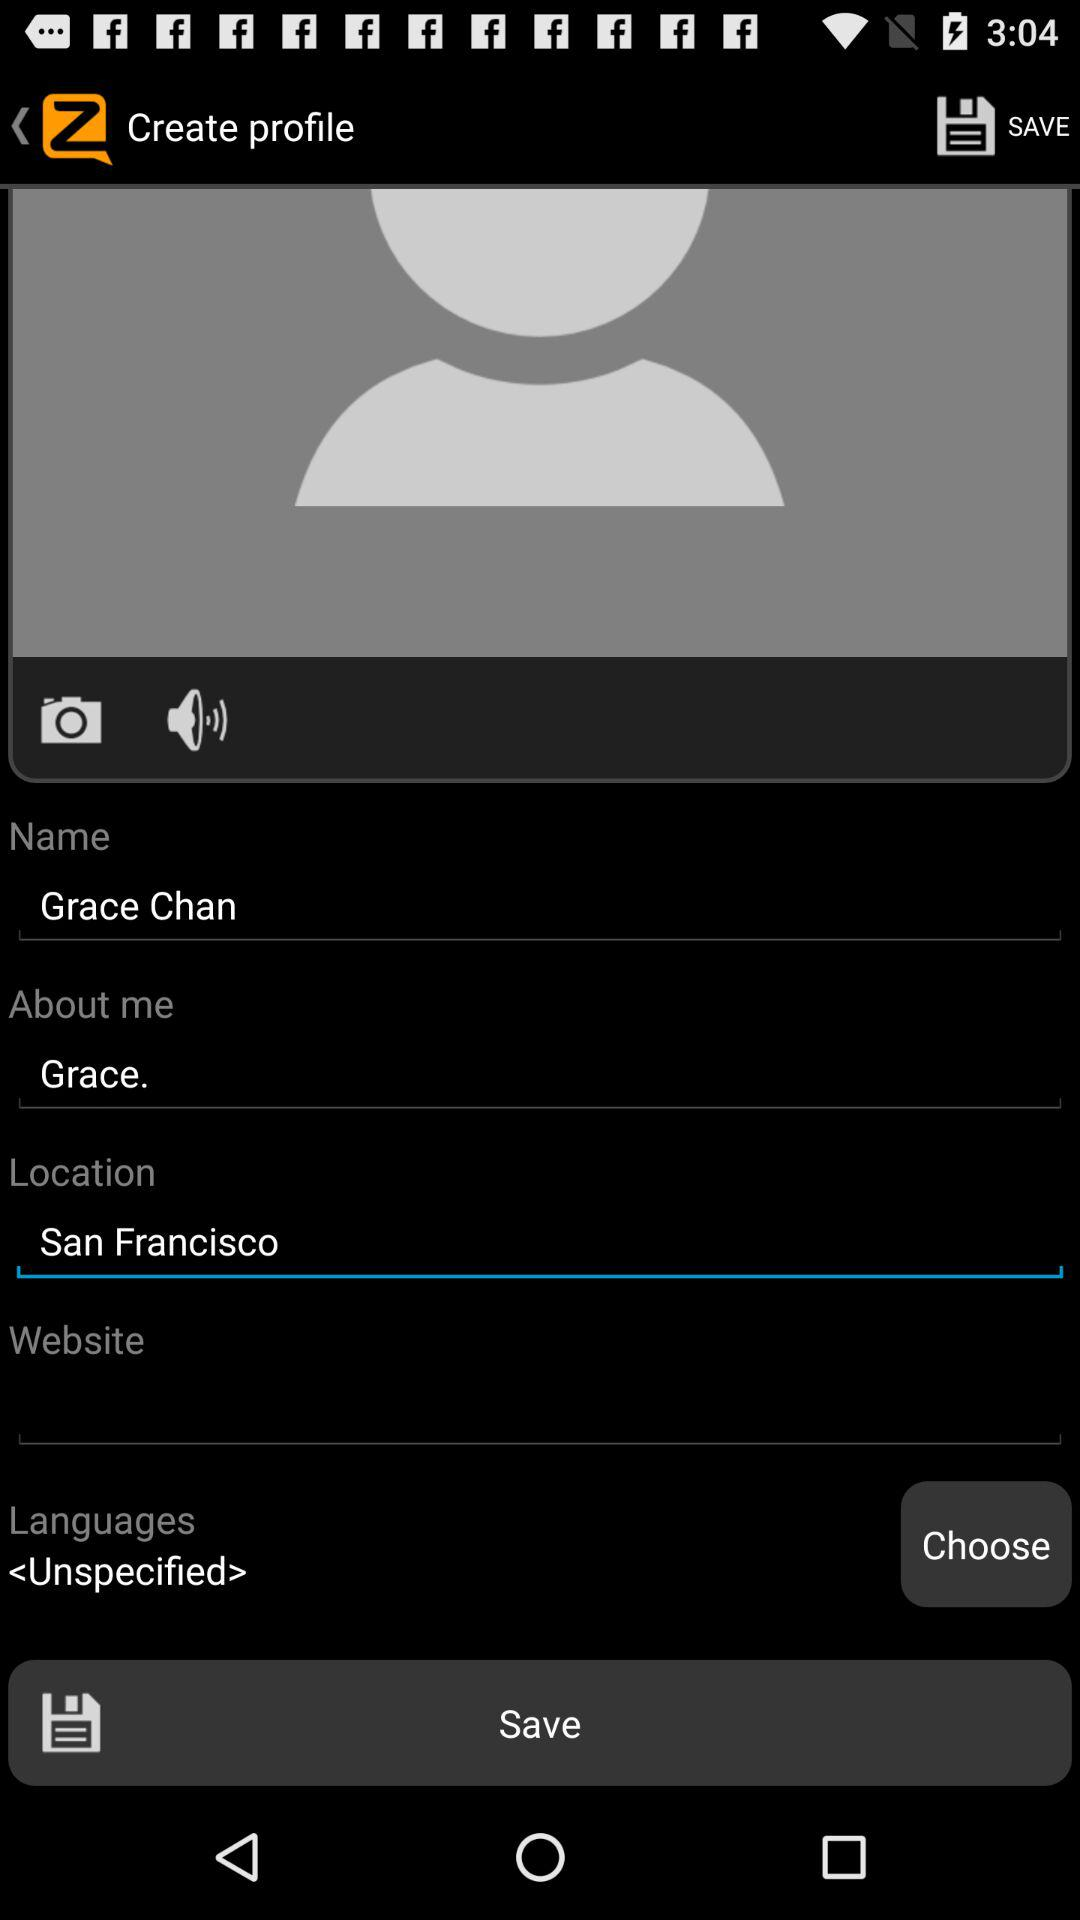What's written in "About me"? In "About me", "Grace." is written. 